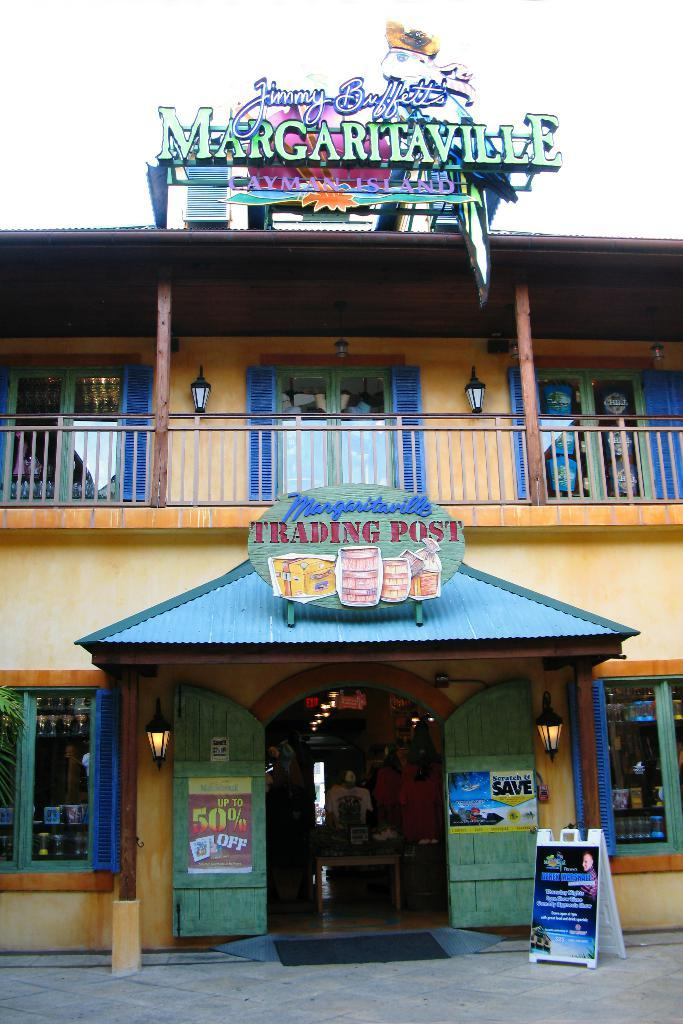Provide a one-sentence caption for the provided image. A Jimmy Buffet's Margaritaville Trading Post store with a 50% off sign on the door. 